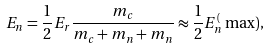<formula> <loc_0><loc_0><loc_500><loc_500>E _ { n } = \frac { 1 } { 2 } E _ { r } \frac { m _ { c } } { m _ { c } + m _ { n } + m _ { n } } \approx \frac { 1 } { 2 } E _ { n } ^ { ( } \max ) ,</formula> 